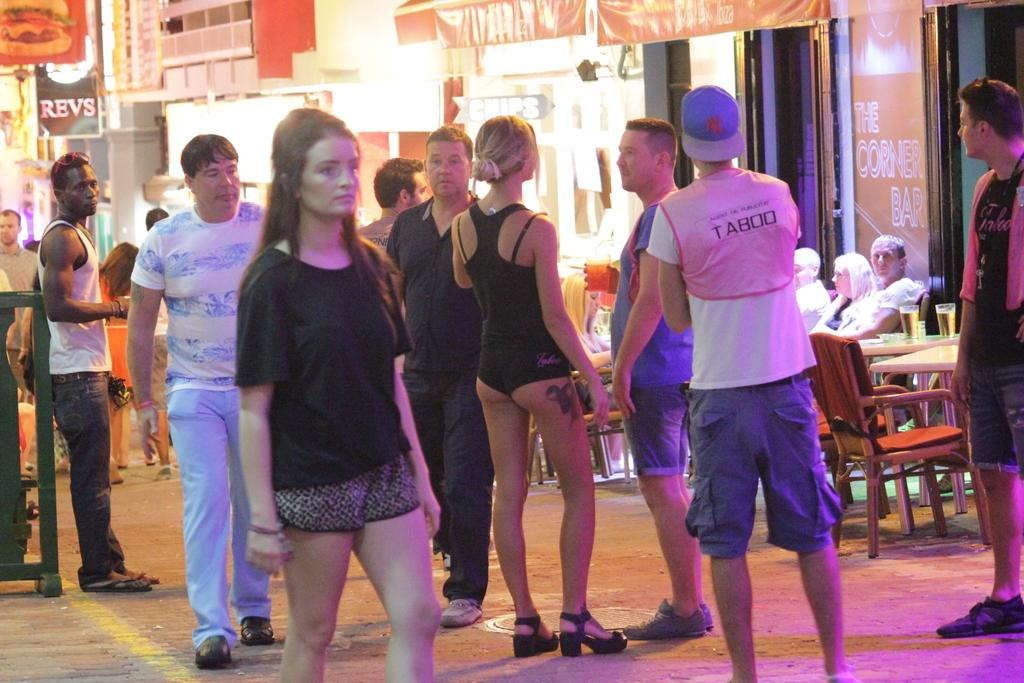How many people are in the image? There is a group of people in the image, but the exact number is not specified. What are the people in the image doing? Some people are standing, while others are sitting on chairs. What type of furniture is present in the image? There are tables and chairs in the image. What objects might be used for drinking in the image? Glasses are present in the image. What type of establishments can be seen in the image? There are shops in the image. What type of signage is visible in the image? Banners are visible in the image. What type of writing surface is present in the image? Boards are present in the image. What type of illumination is visible in the image? Lights are visible in the image. What type of stream can be seen flowing through the image? There is no stream present in the image. What type of grain is visible on the tables in the image? There is no grain present on the tables in the image. 